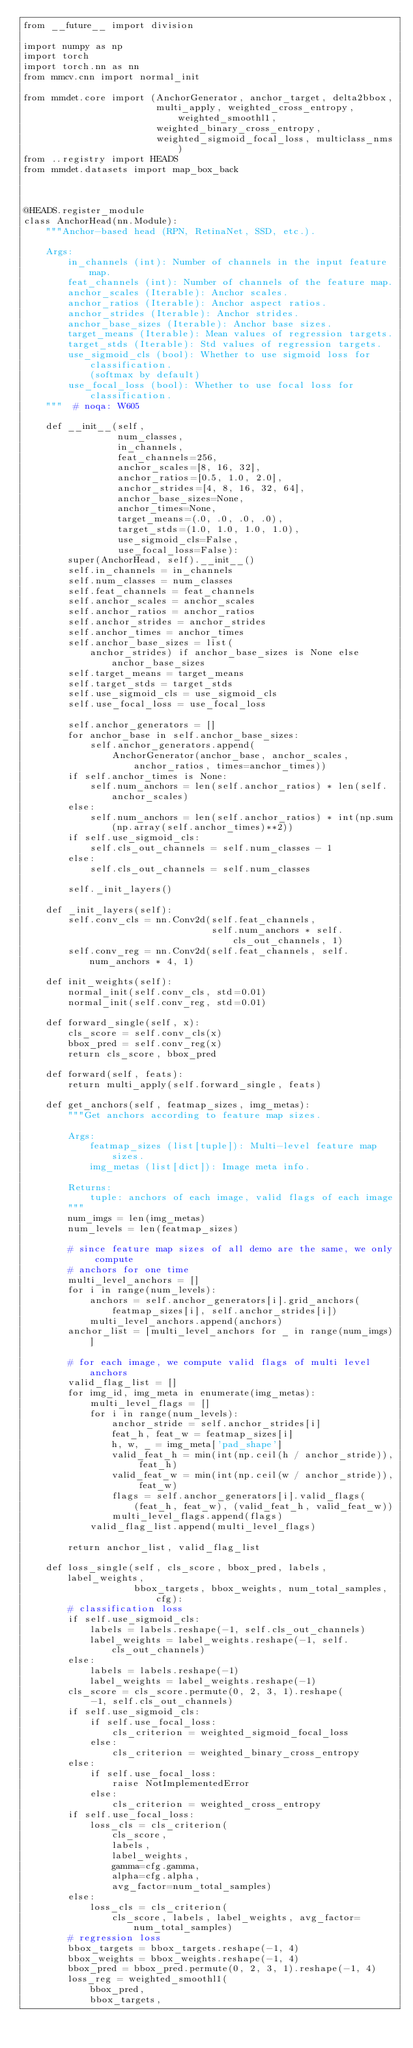Convert code to text. <code><loc_0><loc_0><loc_500><loc_500><_Python_>from __future__ import division

import numpy as np
import torch
import torch.nn as nn
from mmcv.cnn import normal_init

from mmdet.core import (AnchorGenerator, anchor_target, delta2bbox,
                        multi_apply, weighted_cross_entropy, weighted_smoothl1,
                        weighted_binary_cross_entropy,
                        weighted_sigmoid_focal_loss, multiclass_nms)
from ..registry import HEADS
from mmdet.datasets import map_box_back



@HEADS.register_module
class AnchorHead(nn.Module):
    """Anchor-based head (RPN, RetinaNet, SSD, etc.).

    Args:
        in_channels (int): Number of channels in the input feature map.
        feat_channels (int): Number of channels of the feature map.
        anchor_scales (Iterable): Anchor scales.
        anchor_ratios (Iterable): Anchor aspect ratios.
        anchor_strides (Iterable): Anchor strides.
        anchor_base_sizes (Iterable): Anchor base sizes.
        target_means (Iterable): Mean values of regression targets.
        target_stds (Iterable): Std values of regression targets.
        use_sigmoid_cls (bool): Whether to use sigmoid loss for classification.
            (softmax by default)
        use_focal_loss (bool): Whether to use focal loss for classification.
    """  # noqa: W605

    def __init__(self,
                 num_classes,
                 in_channels,
                 feat_channels=256,
                 anchor_scales=[8, 16, 32],
                 anchor_ratios=[0.5, 1.0, 2.0],
                 anchor_strides=[4, 8, 16, 32, 64],
                 anchor_base_sizes=None,
                 anchor_times=None,
                 target_means=(.0, .0, .0, .0),
                 target_stds=(1.0, 1.0, 1.0, 1.0),
                 use_sigmoid_cls=False,
                 use_focal_loss=False):
        super(AnchorHead, self).__init__()
        self.in_channels = in_channels
        self.num_classes = num_classes
        self.feat_channels = feat_channels
        self.anchor_scales = anchor_scales
        self.anchor_ratios = anchor_ratios
        self.anchor_strides = anchor_strides
        self.anchor_times = anchor_times
        self.anchor_base_sizes = list(
            anchor_strides) if anchor_base_sizes is None else anchor_base_sizes
        self.target_means = target_means
        self.target_stds = target_stds
        self.use_sigmoid_cls = use_sigmoid_cls
        self.use_focal_loss = use_focal_loss

        self.anchor_generators = []
        for anchor_base in self.anchor_base_sizes:
            self.anchor_generators.append(
                AnchorGenerator(anchor_base, anchor_scales, anchor_ratios, times=anchor_times))
        if self.anchor_times is None:
            self.num_anchors = len(self.anchor_ratios) * len(self.anchor_scales)
        else:
            self.num_anchors = len(self.anchor_ratios) * int(np.sum(np.array(self.anchor_times)**2))
        if self.use_sigmoid_cls:
            self.cls_out_channels = self.num_classes - 1
        else:
            self.cls_out_channels = self.num_classes

        self._init_layers()

    def _init_layers(self):
        self.conv_cls = nn.Conv2d(self.feat_channels,
                                  self.num_anchors * self.cls_out_channels, 1)
        self.conv_reg = nn.Conv2d(self.feat_channels, self.num_anchors * 4, 1)

    def init_weights(self):
        normal_init(self.conv_cls, std=0.01)
        normal_init(self.conv_reg, std=0.01)

    def forward_single(self, x):
        cls_score = self.conv_cls(x)
        bbox_pred = self.conv_reg(x)
        return cls_score, bbox_pred

    def forward(self, feats):
        return multi_apply(self.forward_single, feats)

    def get_anchors(self, featmap_sizes, img_metas):
        """Get anchors according to feature map sizes.

        Args:
            featmap_sizes (list[tuple]): Multi-level feature map sizes.
            img_metas (list[dict]): Image meta info.

        Returns:
            tuple: anchors of each image, valid flags of each image
        """
        num_imgs = len(img_metas)
        num_levels = len(featmap_sizes)

        # since feature map sizes of all demo are the same, we only compute
        # anchors for one time
        multi_level_anchors = []
        for i in range(num_levels):
            anchors = self.anchor_generators[i].grid_anchors(
                featmap_sizes[i], self.anchor_strides[i])
            multi_level_anchors.append(anchors)
        anchor_list = [multi_level_anchors for _ in range(num_imgs)]

        # for each image, we compute valid flags of multi level anchors
        valid_flag_list = []
        for img_id, img_meta in enumerate(img_metas):
            multi_level_flags = []
            for i in range(num_levels):
                anchor_stride = self.anchor_strides[i]
                feat_h, feat_w = featmap_sizes[i]
                h, w, _ = img_meta['pad_shape']
                valid_feat_h = min(int(np.ceil(h / anchor_stride)), feat_h)
                valid_feat_w = min(int(np.ceil(w / anchor_stride)), feat_w)
                flags = self.anchor_generators[i].valid_flags(
                    (feat_h, feat_w), (valid_feat_h, valid_feat_w))
                multi_level_flags.append(flags)
            valid_flag_list.append(multi_level_flags)

        return anchor_list, valid_flag_list

    def loss_single(self, cls_score, bbox_pred, labels, label_weights,
                    bbox_targets, bbox_weights, num_total_samples, cfg):
        # classification loss
        if self.use_sigmoid_cls:
            labels = labels.reshape(-1, self.cls_out_channels)
            label_weights = label_weights.reshape(-1, self.cls_out_channels)
        else:
            labels = labels.reshape(-1)
            label_weights = label_weights.reshape(-1)
        cls_score = cls_score.permute(0, 2, 3, 1).reshape(
            -1, self.cls_out_channels)
        if self.use_sigmoid_cls:
            if self.use_focal_loss:
                cls_criterion = weighted_sigmoid_focal_loss
            else:
                cls_criterion = weighted_binary_cross_entropy
        else:
            if self.use_focal_loss:
                raise NotImplementedError
            else:
                cls_criterion = weighted_cross_entropy
        if self.use_focal_loss:
            loss_cls = cls_criterion(
                cls_score,
                labels,
                label_weights,
                gamma=cfg.gamma,
                alpha=cfg.alpha,
                avg_factor=num_total_samples)
        else:
            loss_cls = cls_criterion(
                cls_score, labels, label_weights, avg_factor=num_total_samples)
        # regression loss
        bbox_targets = bbox_targets.reshape(-1, 4)
        bbox_weights = bbox_weights.reshape(-1, 4)
        bbox_pred = bbox_pred.permute(0, 2, 3, 1).reshape(-1, 4)
        loss_reg = weighted_smoothl1(
            bbox_pred,
            bbox_targets,</code> 